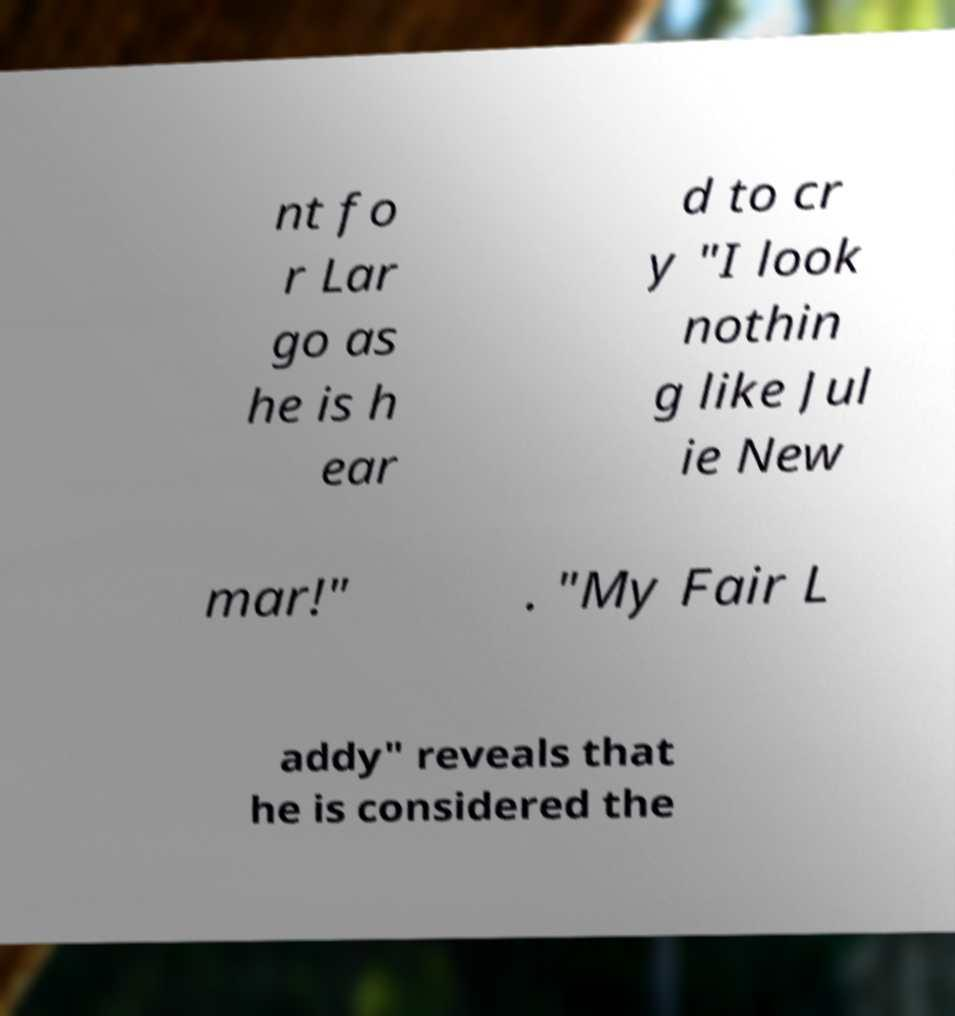Could you assist in decoding the text presented in this image and type it out clearly? nt fo r Lar go as he is h ear d to cr y "I look nothin g like Jul ie New mar!" . "My Fair L addy" reveals that he is considered the 